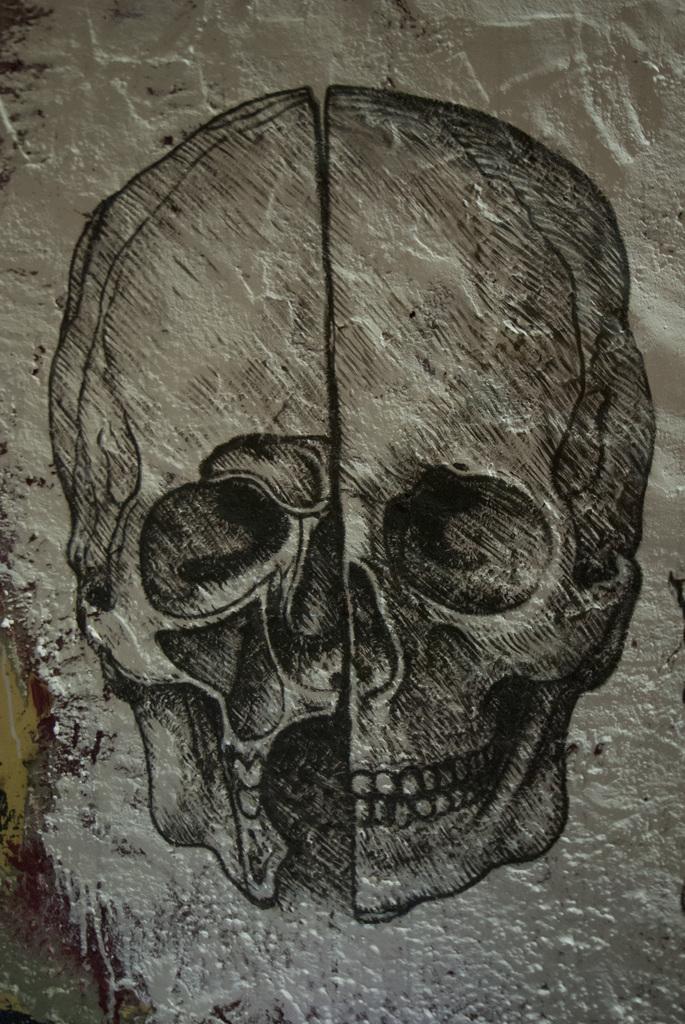In one or two sentences, can you explain what this image depicts? In this image we can see the painting of a human skull on the wall. 